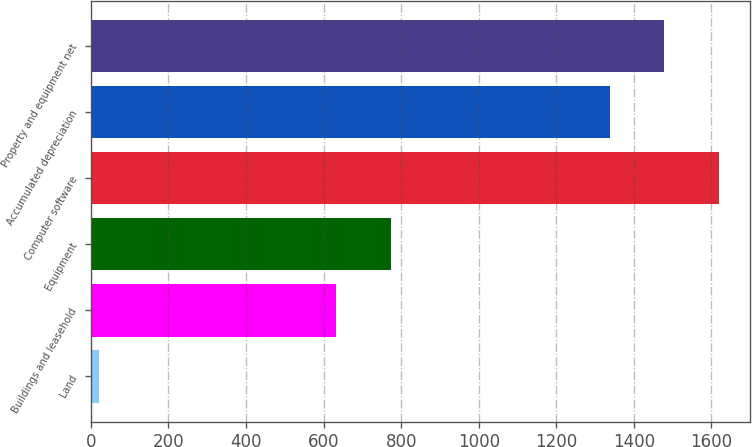Convert chart. <chart><loc_0><loc_0><loc_500><loc_500><bar_chart><fcel>Land<fcel>Buildings and leasehold<fcel>Equipment<fcel>Computer software<fcel>Accumulated depreciation<fcel>Property and equipment net<nl><fcel>20<fcel>633<fcel>773.4<fcel>1618.8<fcel>1338<fcel>1478.4<nl></chart> 